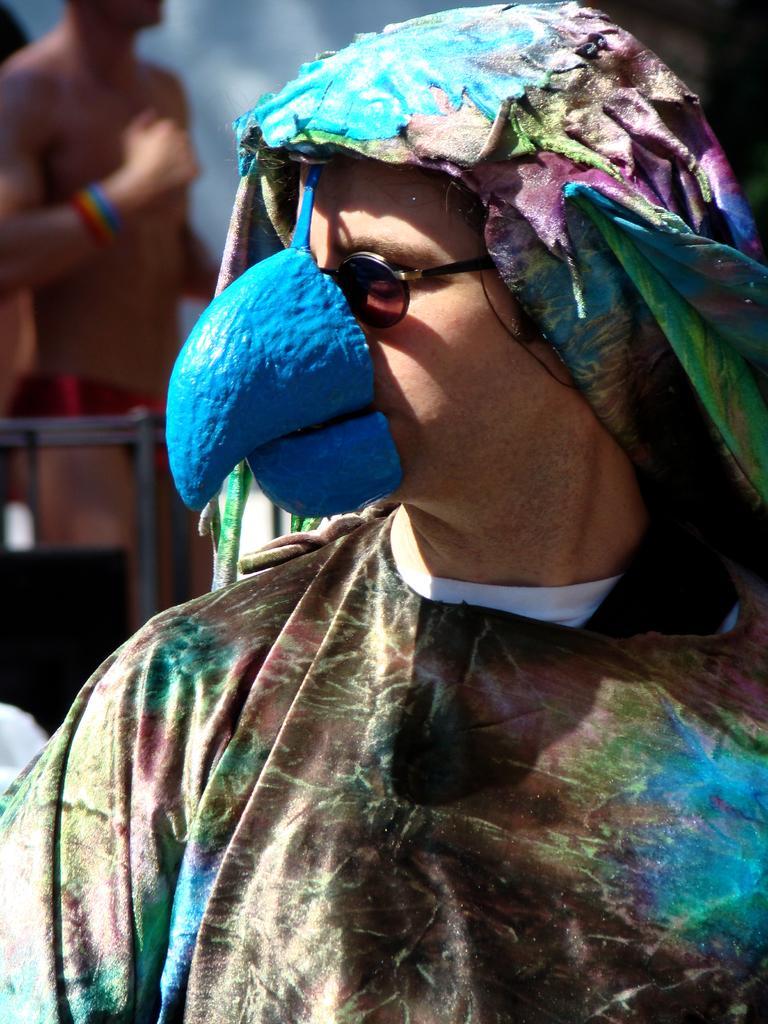Please provide a concise description of this image. In this image I can see a person wearing different color costume. It is in different color. Background is blurred. 